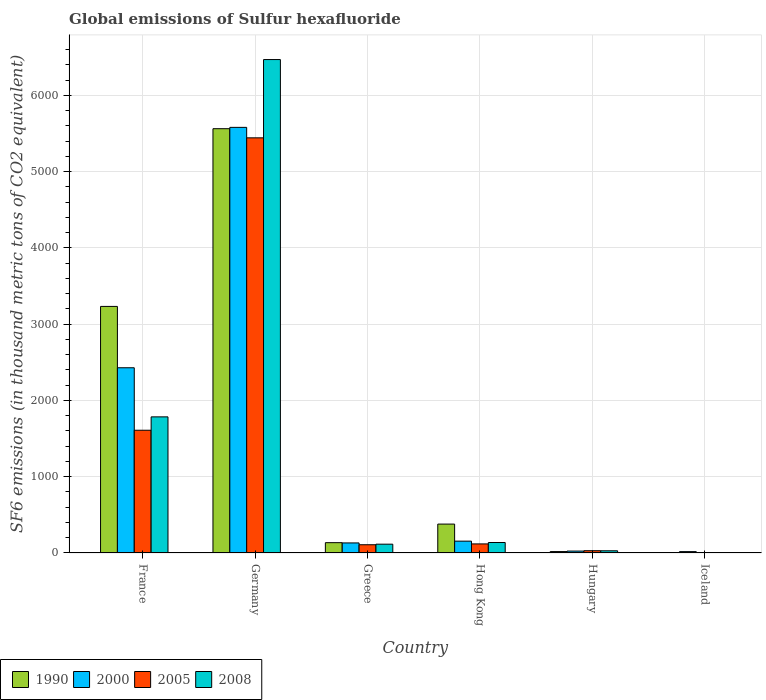How many different coloured bars are there?
Your response must be concise. 4. Are the number of bars per tick equal to the number of legend labels?
Your answer should be very brief. Yes. Are the number of bars on each tick of the X-axis equal?
Offer a terse response. Yes. How many bars are there on the 4th tick from the left?
Offer a terse response. 4. What is the label of the 5th group of bars from the left?
Give a very brief answer. Hungary. Across all countries, what is the maximum global emissions of Sulfur hexafluoride in 2005?
Keep it short and to the point. 5443.2. In which country was the global emissions of Sulfur hexafluoride in 2008 maximum?
Give a very brief answer. Germany. In which country was the global emissions of Sulfur hexafluoride in 2000 minimum?
Your response must be concise. Iceland. What is the total global emissions of Sulfur hexafluoride in 2000 in the graph?
Give a very brief answer. 8339.1. What is the difference between the global emissions of Sulfur hexafluoride in 2005 in France and that in Iceland?
Provide a succinct answer. 1605.9. What is the difference between the global emissions of Sulfur hexafluoride in 1990 in France and the global emissions of Sulfur hexafluoride in 2000 in Germany?
Offer a terse response. -2347.6. What is the average global emissions of Sulfur hexafluoride in 2005 per country?
Provide a succinct answer. 1218.87. What is the difference between the global emissions of Sulfur hexafluoride of/in 2005 and global emissions of Sulfur hexafluoride of/in 2008 in Hong Kong?
Provide a succinct answer. -18.4. What is the ratio of the global emissions of Sulfur hexafluoride in 1990 in Germany to that in Iceland?
Your answer should be compact. 1589.4. Is the global emissions of Sulfur hexafluoride in 1990 in Germany less than that in Hong Kong?
Provide a short and direct response. No. Is the difference between the global emissions of Sulfur hexafluoride in 2005 in France and Hong Kong greater than the difference between the global emissions of Sulfur hexafluoride in 2008 in France and Hong Kong?
Offer a terse response. No. What is the difference between the highest and the second highest global emissions of Sulfur hexafluoride in 1990?
Offer a terse response. -2330.1. What is the difference between the highest and the lowest global emissions of Sulfur hexafluoride in 1990?
Offer a terse response. 5559.4. What does the 3rd bar from the left in Iceland represents?
Offer a very short reply. 2005. What does the 3rd bar from the right in Hungary represents?
Ensure brevity in your answer.  2000. Is it the case that in every country, the sum of the global emissions of Sulfur hexafluoride in 2008 and global emissions of Sulfur hexafluoride in 1990 is greater than the global emissions of Sulfur hexafluoride in 2000?
Offer a very short reply. No. Are all the bars in the graph horizontal?
Your response must be concise. No. How many countries are there in the graph?
Give a very brief answer. 6. What is the difference between two consecutive major ticks on the Y-axis?
Provide a short and direct response. 1000. Are the values on the major ticks of Y-axis written in scientific E-notation?
Offer a terse response. No. How many legend labels are there?
Offer a very short reply. 4. How are the legend labels stacked?
Your response must be concise. Horizontal. What is the title of the graph?
Your response must be concise. Global emissions of Sulfur hexafluoride. Does "1979" appear as one of the legend labels in the graph?
Provide a succinct answer. No. What is the label or title of the X-axis?
Your response must be concise. Country. What is the label or title of the Y-axis?
Provide a short and direct response. SF6 emissions (in thousand metric tons of CO2 equivalent). What is the SF6 emissions (in thousand metric tons of CO2 equivalent) in 1990 in France?
Provide a short and direct response. 3232.8. What is the SF6 emissions (in thousand metric tons of CO2 equivalent) of 2000 in France?
Your response must be concise. 2428.5. What is the SF6 emissions (in thousand metric tons of CO2 equivalent) in 2005 in France?
Offer a very short reply. 1609.4. What is the SF6 emissions (in thousand metric tons of CO2 equivalent) in 2008 in France?
Offer a very short reply. 1784.7. What is the SF6 emissions (in thousand metric tons of CO2 equivalent) of 1990 in Germany?
Make the answer very short. 5562.9. What is the SF6 emissions (in thousand metric tons of CO2 equivalent) in 2000 in Germany?
Provide a succinct answer. 5580.4. What is the SF6 emissions (in thousand metric tons of CO2 equivalent) in 2005 in Germany?
Give a very brief answer. 5443.2. What is the SF6 emissions (in thousand metric tons of CO2 equivalent) in 2008 in Germany?
Give a very brief answer. 6469.6. What is the SF6 emissions (in thousand metric tons of CO2 equivalent) of 1990 in Greece?
Your answer should be compact. 135.4. What is the SF6 emissions (in thousand metric tons of CO2 equivalent) in 2000 in Greece?
Ensure brevity in your answer.  131.8. What is the SF6 emissions (in thousand metric tons of CO2 equivalent) of 2005 in Greece?
Make the answer very short. 108.1. What is the SF6 emissions (in thousand metric tons of CO2 equivalent) of 2008 in Greece?
Keep it short and to the point. 115.4. What is the SF6 emissions (in thousand metric tons of CO2 equivalent) in 1990 in Hong Kong?
Your response must be concise. 379. What is the SF6 emissions (in thousand metric tons of CO2 equivalent) in 2000 in Hong Kong?
Keep it short and to the point. 155.3. What is the SF6 emissions (in thousand metric tons of CO2 equivalent) in 2005 in Hong Kong?
Offer a terse response. 119. What is the SF6 emissions (in thousand metric tons of CO2 equivalent) of 2008 in Hong Kong?
Ensure brevity in your answer.  137.4. What is the SF6 emissions (in thousand metric tons of CO2 equivalent) of 2000 in Hungary?
Provide a short and direct response. 25.2. What is the SF6 emissions (in thousand metric tons of CO2 equivalent) of 2008 in Hungary?
Provide a short and direct response. 28.9. What is the SF6 emissions (in thousand metric tons of CO2 equivalent) of 1990 in Iceland?
Make the answer very short. 3.5. What is the SF6 emissions (in thousand metric tons of CO2 equivalent) in 2005 in Iceland?
Your response must be concise. 3.5. Across all countries, what is the maximum SF6 emissions (in thousand metric tons of CO2 equivalent) in 1990?
Give a very brief answer. 5562.9. Across all countries, what is the maximum SF6 emissions (in thousand metric tons of CO2 equivalent) of 2000?
Provide a short and direct response. 5580.4. Across all countries, what is the maximum SF6 emissions (in thousand metric tons of CO2 equivalent) of 2005?
Provide a succinct answer. 5443.2. Across all countries, what is the maximum SF6 emissions (in thousand metric tons of CO2 equivalent) in 2008?
Your answer should be very brief. 6469.6. Across all countries, what is the minimum SF6 emissions (in thousand metric tons of CO2 equivalent) of 1990?
Keep it short and to the point. 3.5. Across all countries, what is the minimum SF6 emissions (in thousand metric tons of CO2 equivalent) in 2005?
Provide a short and direct response. 3.5. Across all countries, what is the minimum SF6 emissions (in thousand metric tons of CO2 equivalent) in 2008?
Offer a terse response. 4. What is the total SF6 emissions (in thousand metric tons of CO2 equivalent) in 1990 in the graph?
Your response must be concise. 9332.2. What is the total SF6 emissions (in thousand metric tons of CO2 equivalent) of 2000 in the graph?
Provide a succinct answer. 8339.1. What is the total SF6 emissions (in thousand metric tons of CO2 equivalent) in 2005 in the graph?
Your answer should be compact. 7313.2. What is the total SF6 emissions (in thousand metric tons of CO2 equivalent) of 2008 in the graph?
Offer a very short reply. 8540. What is the difference between the SF6 emissions (in thousand metric tons of CO2 equivalent) in 1990 in France and that in Germany?
Offer a terse response. -2330.1. What is the difference between the SF6 emissions (in thousand metric tons of CO2 equivalent) in 2000 in France and that in Germany?
Provide a short and direct response. -3151.9. What is the difference between the SF6 emissions (in thousand metric tons of CO2 equivalent) of 2005 in France and that in Germany?
Your answer should be very brief. -3833.8. What is the difference between the SF6 emissions (in thousand metric tons of CO2 equivalent) in 2008 in France and that in Germany?
Keep it short and to the point. -4684.9. What is the difference between the SF6 emissions (in thousand metric tons of CO2 equivalent) of 1990 in France and that in Greece?
Provide a short and direct response. 3097.4. What is the difference between the SF6 emissions (in thousand metric tons of CO2 equivalent) in 2000 in France and that in Greece?
Give a very brief answer. 2296.7. What is the difference between the SF6 emissions (in thousand metric tons of CO2 equivalent) in 2005 in France and that in Greece?
Provide a succinct answer. 1501.3. What is the difference between the SF6 emissions (in thousand metric tons of CO2 equivalent) of 2008 in France and that in Greece?
Your response must be concise. 1669.3. What is the difference between the SF6 emissions (in thousand metric tons of CO2 equivalent) of 1990 in France and that in Hong Kong?
Make the answer very short. 2853.8. What is the difference between the SF6 emissions (in thousand metric tons of CO2 equivalent) of 2000 in France and that in Hong Kong?
Offer a terse response. 2273.2. What is the difference between the SF6 emissions (in thousand metric tons of CO2 equivalent) of 2005 in France and that in Hong Kong?
Give a very brief answer. 1490.4. What is the difference between the SF6 emissions (in thousand metric tons of CO2 equivalent) in 2008 in France and that in Hong Kong?
Your answer should be compact. 1647.3. What is the difference between the SF6 emissions (in thousand metric tons of CO2 equivalent) in 1990 in France and that in Hungary?
Offer a terse response. 3214.2. What is the difference between the SF6 emissions (in thousand metric tons of CO2 equivalent) in 2000 in France and that in Hungary?
Offer a terse response. 2403.3. What is the difference between the SF6 emissions (in thousand metric tons of CO2 equivalent) of 2005 in France and that in Hungary?
Keep it short and to the point. 1579.4. What is the difference between the SF6 emissions (in thousand metric tons of CO2 equivalent) in 2008 in France and that in Hungary?
Ensure brevity in your answer.  1755.8. What is the difference between the SF6 emissions (in thousand metric tons of CO2 equivalent) in 1990 in France and that in Iceland?
Your response must be concise. 3229.3. What is the difference between the SF6 emissions (in thousand metric tons of CO2 equivalent) in 2000 in France and that in Iceland?
Keep it short and to the point. 2410.6. What is the difference between the SF6 emissions (in thousand metric tons of CO2 equivalent) in 2005 in France and that in Iceland?
Provide a short and direct response. 1605.9. What is the difference between the SF6 emissions (in thousand metric tons of CO2 equivalent) of 2008 in France and that in Iceland?
Provide a succinct answer. 1780.7. What is the difference between the SF6 emissions (in thousand metric tons of CO2 equivalent) in 1990 in Germany and that in Greece?
Provide a short and direct response. 5427.5. What is the difference between the SF6 emissions (in thousand metric tons of CO2 equivalent) of 2000 in Germany and that in Greece?
Give a very brief answer. 5448.6. What is the difference between the SF6 emissions (in thousand metric tons of CO2 equivalent) in 2005 in Germany and that in Greece?
Provide a short and direct response. 5335.1. What is the difference between the SF6 emissions (in thousand metric tons of CO2 equivalent) of 2008 in Germany and that in Greece?
Ensure brevity in your answer.  6354.2. What is the difference between the SF6 emissions (in thousand metric tons of CO2 equivalent) of 1990 in Germany and that in Hong Kong?
Provide a succinct answer. 5183.9. What is the difference between the SF6 emissions (in thousand metric tons of CO2 equivalent) in 2000 in Germany and that in Hong Kong?
Give a very brief answer. 5425.1. What is the difference between the SF6 emissions (in thousand metric tons of CO2 equivalent) of 2005 in Germany and that in Hong Kong?
Provide a succinct answer. 5324.2. What is the difference between the SF6 emissions (in thousand metric tons of CO2 equivalent) in 2008 in Germany and that in Hong Kong?
Your response must be concise. 6332.2. What is the difference between the SF6 emissions (in thousand metric tons of CO2 equivalent) in 1990 in Germany and that in Hungary?
Provide a succinct answer. 5544.3. What is the difference between the SF6 emissions (in thousand metric tons of CO2 equivalent) in 2000 in Germany and that in Hungary?
Your answer should be very brief. 5555.2. What is the difference between the SF6 emissions (in thousand metric tons of CO2 equivalent) in 2005 in Germany and that in Hungary?
Keep it short and to the point. 5413.2. What is the difference between the SF6 emissions (in thousand metric tons of CO2 equivalent) in 2008 in Germany and that in Hungary?
Your response must be concise. 6440.7. What is the difference between the SF6 emissions (in thousand metric tons of CO2 equivalent) in 1990 in Germany and that in Iceland?
Provide a succinct answer. 5559.4. What is the difference between the SF6 emissions (in thousand metric tons of CO2 equivalent) in 2000 in Germany and that in Iceland?
Your answer should be very brief. 5562.5. What is the difference between the SF6 emissions (in thousand metric tons of CO2 equivalent) in 2005 in Germany and that in Iceland?
Your answer should be very brief. 5439.7. What is the difference between the SF6 emissions (in thousand metric tons of CO2 equivalent) in 2008 in Germany and that in Iceland?
Make the answer very short. 6465.6. What is the difference between the SF6 emissions (in thousand metric tons of CO2 equivalent) in 1990 in Greece and that in Hong Kong?
Your answer should be very brief. -243.6. What is the difference between the SF6 emissions (in thousand metric tons of CO2 equivalent) in 2000 in Greece and that in Hong Kong?
Provide a succinct answer. -23.5. What is the difference between the SF6 emissions (in thousand metric tons of CO2 equivalent) of 1990 in Greece and that in Hungary?
Your answer should be compact. 116.8. What is the difference between the SF6 emissions (in thousand metric tons of CO2 equivalent) of 2000 in Greece and that in Hungary?
Make the answer very short. 106.6. What is the difference between the SF6 emissions (in thousand metric tons of CO2 equivalent) of 2005 in Greece and that in Hungary?
Your answer should be very brief. 78.1. What is the difference between the SF6 emissions (in thousand metric tons of CO2 equivalent) of 2008 in Greece and that in Hungary?
Keep it short and to the point. 86.5. What is the difference between the SF6 emissions (in thousand metric tons of CO2 equivalent) in 1990 in Greece and that in Iceland?
Offer a terse response. 131.9. What is the difference between the SF6 emissions (in thousand metric tons of CO2 equivalent) in 2000 in Greece and that in Iceland?
Offer a terse response. 113.9. What is the difference between the SF6 emissions (in thousand metric tons of CO2 equivalent) in 2005 in Greece and that in Iceland?
Offer a terse response. 104.6. What is the difference between the SF6 emissions (in thousand metric tons of CO2 equivalent) of 2008 in Greece and that in Iceland?
Ensure brevity in your answer.  111.4. What is the difference between the SF6 emissions (in thousand metric tons of CO2 equivalent) in 1990 in Hong Kong and that in Hungary?
Your answer should be compact. 360.4. What is the difference between the SF6 emissions (in thousand metric tons of CO2 equivalent) in 2000 in Hong Kong and that in Hungary?
Ensure brevity in your answer.  130.1. What is the difference between the SF6 emissions (in thousand metric tons of CO2 equivalent) of 2005 in Hong Kong and that in Hungary?
Provide a succinct answer. 89. What is the difference between the SF6 emissions (in thousand metric tons of CO2 equivalent) of 2008 in Hong Kong and that in Hungary?
Keep it short and to the point. 108.5. What is the difference between the SF6 emissions (in thousand metric tons of CO2 equivalent) in 1990 in Hong Kong and that in Iceland?
Give a very brief answer. 375.5. What is the difference between the SF6 emissions (in thousand metric tons of CO2 equivalent) in 2000 in Hong Kong and that in Iceland?
Offer a very short reply. 137.4. What is the difference between the SF6 emissions (in thousand metric tons of CO2 equivalent) of 2005 in Hong Kong and that in Iceland?
Ensure brevity in your answer.  115.5. What is the difference between the SF6 emissions (in thousand metric tons of CO2 equivalent) in 2008 in Hong Kong and that in Iceland?
Ensure brevity in your answer.  133.4. What is the difference between the SF6 emissions (in thousand metric tons of CO2 equivalent) in 1990 in Hungary and that in Iceland?
Offer a terse response. 15.1. What is the difference between the SF6 emissions (in thousand metric tons of CO2 equivalent) in 2000 in Hungary and that in Iceland?
Your answer should be compact. 7.3. What is the difference between the SF6 emissions (in thousand metric tons of CO2 equivalent) of 2005 in Hungary and that in Iceland?
Offer a very short reply. 26.5. What is the difference between the SF6 emissions (in thousand metric tons of CO2 equivalent) in 2008 in Hungary and that in Iceland?
Provide a short and direct response. 24.9. What is the difference between the SF6 emissions (in thousand metric tons of CO2 equivalent) of 1990 in France and the SF6 emissions (in thousand metric tons of CO2 equivalent) of 2000 in Germany?
Offer a terse response. -2347.6. What is the difference between the SF6 emissions (in thousand metric tons of CO2 equivalent) in 1990 in France and the SF6 emissions (in thousand metric tons of CO2 equivalent) in 2005 in Germany?
Keep it short and to the point. -2210.4. What is the difference between the SF6 emissions (in thousand metric tons of CO2 equivalent) in 1990 in France and the SF6 emissions (in thousand metric tons of CO2 equivalent) in 2008 in Germany?
Offer a terse response. -3236.8. What is the difference between the SF6 emissions (in thousand metric tons of CO2 equivalent) of 2000 in France and the SF6 emissions (in thousand metric tons of CO2 equivalent) of 2005 in Germany?
Give a very brief answer. -3014.7. What is the difference between the SF6 emissions (in thousand metric tons of CO2 equivalent) in 2000 in France and the SF6 emissions (in thousand metric tons of CO2 equivalent) in 2008 in Germany?
Ensure brevity in your answer.  -4041.1. What is the difference between the SF6 emissions (in thousand metric tons of CO2 equivalent) of 2005 in France and the SF6 emissions (in thousand metric tons of CO2 equivalent) of 2008 in Germany?
Offer a very short reply. -4860.2. What is the difference between the SF6 emissions (in thousand metric tons of CO2 equivalent) of 1990 in France and the SF6 emissions (in thousand metric tons of CO2 equivalent) of 2000 in Greece?
Offer a very short reply. 3101. What is the difference between the SF6 emissions (in thousand metric tons of CO2 equivalent) of 1990 in France and the SF6 emissions (in thousand metric tons of CO2 equivalent) of 2005 in Greece?
Give a very brief answer. 3124.7. What is the difference between the SF6 emissions (in thousand metric tons of CO2 equivalent) of 1990 in France and the SF6 emissions (in thousand metric tons of CO2 equivalent) of 2008 in Greece?
Ensure brevity in your answer.  3117.4. What is the difference between the SF6 emissions (in thousand metric tons of CO2 equivalent) in 2000 in France and the SF6 emissions (in thousand metric tons of CO2 equivalent) in 2005 in Greece?
Provide a short and direct response. 2320.4. What is the difference between the SF6 emissions (in thousand metric tons of CO2 equivalent) of 2000 in France and the SF6 emissions (in thousand metric tons of CO2 equivalent) of 2008 in Greece?
Provide a short and direct response. 2313.1. What is the difference between the SF6 emissions (in thousand metric tons of CO2 equivalent) of 2005 in France and the SF6 emissions (in thousand metric tons of CO2 equivalent) of 2008 in Greece?
Offer a terse response. 1494. What is the difference between the SF6 emissions (in thousand metric tons of CO2 equivalent) of 1990 in France and the SF6 emissions (in thousand metric tons of CO2 equivalent) of 2000 in Hong Kong?
Your answer should be compact. 3077.5. What is the difference between the SF6 emissions (in thousand metric tons of CO2 equivalent) of 1990 in France and the SF6 emissions (in thousand metric tons of CO2 equivalent) of 2005 in Hong Kong?
Ensure brevity in your answer.  3113.8. What is the difference between the SF6 emissions (in thousand metric tons of CO2 equivalent) of 1990 in France and the SF6 emissions (in thousand metric tons of CO2 equivalent) of 2008 in Hong Kong?
Provide a short and direct response. 3095.4. What is the difference between the SF6 emissions (in thousand metric tons of CO2 equivalent) in 2000 in France and the SF6 emissions (in thousand metric tons of CO2 equivalent) in 2005 in Hong Kong?
Provide a short and direct response. 2309.5. What is the difference between the SF6 emissions (in thousand metric tons of CO2 equivalent) of 2000 in France and the SF6 emissions (in thousand metric tons of CO2 equivalent) of 2008 in Hong Kong?
Your response must be concise. 2291.1. What is the difference between the SF6 emissions (in thousand metric tons of CO2 equivalent) in 2005 in France and the SF6 emissions (in thousand metric tons of CO2 equivalent) in 2008 in Hong Kong?
Your answer should be very brief. 1472. What is the difference between the SF6 emissions (in thousand metric tons of CO2 equivalent) in 1990 in France and the SF6 emissions (in thousand metric tons of CO2 equivalent) in 2000 in Hungary?
Provide a succinct answer. 3207.6. What is the difference between the SF6 emissions (in thousand metric tons of CO2 equivalent) in 1990 in France and the SF6 emissions (in thousand metric tons of CO2 equivalent) in 2005 in Hungary?
Offer a terse response. 3202.8. What is the difference between the SF6 emissions (in thousand metric tons of CO2 equivalent) in 1990 in France and the SF6 emissions (in thousand metric tons of CO2 equivalent) in 2008 in Hungary?
Your answer should be compact. 3203.9. What is the difference between the SF6 emissions (in thousand metric tons of CO2 equivalent) of 2000 in France and the SF6 emissions (in thousand metric tons of CO2 equivalent) of 2005 in Hungary?
Offer a terse response. 2398.5. What is the difference between the SF6 emissions (in thousand metric tons of CO2 equivalent) in 2000 in France and the SF6 emissions (in thousand metric tons of CO2 equivalent) in 2008 in Hungary?
Offer a terse response. 2399.6. What is the difference between the SF6 emissions (in thousand metric tons of CO2 equivalent) of 2005 in France and the SF6 emissions (in thousand metric tons of CO2 equivalent) of 2008 in Hungary?
Offer a terse response. 1580.5. What is the difference between the SF6 emissions (in thousand metric tons of CO2 equivalent) in 1990 in France and the SF6 emissions (in thousand metric tons of CO2 equivalent) in 2000 in Iceland?
Give a very brief answer. 3214.9. What is the difference between the SF6 emissions (in thousand metric tons of CO2 equivalent) of 1990 in France and the SF6 emissions (in thousand metric tons of CO2 equivalent) of 2005 in Iceland?
Make the answer very short. 3229.3. What is the difference between the SF6 emissions (in thousand metric tons of CO2 equivalent) of 1990 in France and the SF6 emissions (in thousand metric tons of CO2 equivalent) of 2008 in Iceland?
Your response must be concise. 3228.8. What is the difference between the SF6 emissions (in thousand metric tons of CO2 equivalent) in 2000 in France and the SF6 emissions (in thousand metric tons of CO2 equivalent) in 2005 in Iceland?
Offer a terse response. 2425. What is the difference between the SF6 emissions (in thousand metric tons of CO2 equivalent) of 2000 in France and the SF6 emissions (in thousand metric tons of CO2 equivalent) of 2008 in Iceland?
Give a very brief answer. 2424.5. What is the difference between the SF6 emissions (in thousand metric tons of CO2 equivalent) in 2005 in France and the SF6 emissions (in thousand metric tons of CO2 equivalent) in 2008 in Iceland?
Your answer should be very brief. 1605.4. What is the difference between the SF6 emissions (in thousand metric tons of CO2 equivalent) of 1990 in Germany and the SF6 emissions (in thousand metric tons of CO2 equivalent) of 2000 in Greece?
Your answer should be very brief. 5431.1. What is the difference between the SF6 emissions (in thousand metric tons of CO2 equivalent) in 1990 in Germany and the SF6 emissions (in thousand metric tons of CO2 equivalent) in 2005 in Greece?
Ensure brevity in your answer.  5454.8. What is the difference between the SF6 emissions (in thousand metric tons of CO2 equivalent) in 1990 in Germany and the SF6 emissions (in thousand metric tons of CO2 equivalent) in 2008 in Greece?
Keep it short and to the point. 5447.5. What is the difference between the SF6 emissions (in thousand metric tons of CO2 equivalent) in 2000 in Germany and the SF6 emissions (in thousand metric tons of CO2 equivalent) in 2005 in Greece?
Make the answer very short. 5472.3. What is the difference between the SF6 emissions (in thousand metric tons of CO2 equivalent) in 2000 in Germany and the SF6 emissions (in thousand metric tons of CO2 equivalent) in 2008 in Greece?
Keep it short and to the point. 5465. What is the difference between the SF6 emissions (in thousand metric tons of CO2 equivalent) in 2005 in Germany and the SF6 emissions (in thousand metric tons of CO2 equivalent) in 2008 in Greece?
Offer a terse response. 5327.8. What is the difference between the SF6 emissions (in thousand metric tons of CO2 equivalent) of 1990 in Germany and the SF6 emissions (in thousand metric tons of CO2 equivalent) of 2000 in Hong Kong?
Keep it short and to the point. 5407.6. What is the difference between the SF6 emissions (in thousand metric tons of CO2 equivalent) in 1990 in Germany and the SF6 emissions (in thousand metric tons of CO2 equivalent) in 2005 in Hong Kong?
Give a very brief answer. 5443.9. What is the difference between the SF6 emissions (in thousand metric tons of CO2 equivalent) of 1990 in Germany and the SF6 emissions (in thousand metric tons of CO2 equivalent) of 2008 in Hong Kong?
Give a very brief answer. 5425.5. What is the difference between the SF6 emissions (in thousand metric tons of CO2 equivalent) in 2000 in Germany and the SF6 emissions (in thousand metric tons of CO2 equivalent) in 2005 in Hong Kong?
Provide a succinct answer. 5461.4. What is the difference between the SF6 emissions (in thousand metric tons of CO2 equivalent) of 2000 in Germany and the SF6 emissions (in thousand metric tons of CO2 equivalent) of 2008 in Hong Kong?
Provide a short and direct response. 5443. What is the difference between the SF6 emissions (in thousand metric tons of CO2 equivalent) in 2005 in Germany and the SF6 emissions (in thousand metric tons of CO2 equivalent) in 2008 in Hong Kong?
Provide a succinct answer. 5305.8. What is the difference between the SF6 emissions (in thousand metric tons of CO2 equivalent) of 1990 in Germany and the SF6 emissions (in thousand metric tons of CO2 equivalent) of 2000 in Hungary?
Offer a terse response. 5537.7. What is the difference between the SF6 emissions (in thousand metric tons of CO2 equivalent) of 1990 in Germany and the SF6 emissions (in thousand metric tons of CO2 equivalent) of 2005 in Hungary?
Offer a very short reply. 5532.9. What is the difference between the SF6 emissions (in thousand metric tons of CO2 equivalent) of 1990 in Germany and the SF6 emissions (in thousand metric tons of CO2 equivalent) of 2008 in Hungary?
Keep it short and to the point. 5534. What is the difference between the SF6 emissions (in thousand metric tons of CO2 equivalent) in 2000 in Germany and the SF6 emissions (in thousand metric tons of CO2 equivalent) in 2005 in Hungary?
Provide a succinct answer. 5550.4. What is the difference between the SF6 emissions (in thousand metric tons of CO2 equivalent) of 2000 in Germany and the SF6 emissions (in thousand metric tons of CO2 equivalent) of 2008 in Hungary?
Give a very brief answer. 5551.5. What is the difference between the SF6 emissions (in thousand metric tons of CO2 equivalent) in 2005 in Germany and the SF6 emissions (in thousand metric tons of CO2 equivalent) in 2008 in Hungary?
Give a very brief answer. 5414.3. What is the difference between the SF6 emissions (in thousand metric tons of CO2 equivalent) in 1990 in Germany and the SF6 emissions (in thousand metric tons of CO2 equivalent) in 2000 in Iceland?
Your answer should be very brief. 5545. What is the difference between the SF6 emissions (in thousand metric tons of CO2 equivalent) of 1990 in Germany and the SF6 emissions (in thousand metric tons of CO2 equivalent) of 2005 in Iceland?
Offer a terse response. 5559.4. What is the difference between the SF6 emissions (in thousand metric tons of CO2 equivalent) of 1990 in Germany and the SF6 emissions (in thousand metric tons of CO2 equivalent) of 2008 in Iceland?
Your response must be concise. 5558.9. What is the difference between the SF6 emissions (in thousand metric tons of CO2 equivalent) in 2000 in Germany and the SF6 emissions (in thousand metric tons of CO2 equivalent) in 2005 in Iceland?
Keep it short and to the point. 5576.9. What is the difference between the SF6 emissions (in thousand metric tons of CO2 equivalent) in 2000 in Germany and the SF6 emissions (in thousand metric tons of CO2 equivalent) in 2008 in Iceland?
Your answer should be compact. 5576.4. What is the difference between the SF6 emissions (in thousand metric tons of CO2 equivalent) in 2005 in Germany and the SF6 emissions (in thousand metric tons of CO2 equivalent) in 2008 in Iceland?
Make the answer very short. 5439.2. What is the difference between the SF6 emissions (in thousand metric tons of CO2 equivalent) in 1990 in Greece and the SF6 emissions (in thousand metric tons of CO2 equivalent) in 2000 in Hong Kong?
Provide a succinct answer. -19.9. What is the difference between the SF6 emissions (in thousand metric tons of CO2 equivalent) of 1990 in Greece and the SF6 emissions (in thousand metric tons of CO2 equivalent) of 2005 in Hong Kong?
Keep it short and to the point. 16.4. What is the difference between the SF6 emissions (in thousand metric tons of CO2 equivalent) of 1990 in Greece and the SF6 emissions (in thousand metric tons of CO2 equivalent) of 2008 in Hong Kong?
Your answer should be very brief. -2. What is the difference between the SF6 emissions (in thousand metric tons of CO2 equivalent) of 2000 in Greece and the SF6 emissions (in thousand metric tons of CO2 equivalent) of 2005 in Hong Kong?
Your answer should be compact. 12.8. What is the difference between the SF6 emissions (in thousand metric tons of CO2 equivalent) in 2005 in Greece and the SF6 emissions (in thousand metric tons of CO2 equivalent) in 2008 in Hong Kong?
Provide a short and direct response. -29.3. What is the difference between the SF6 emissions (in thousand metric tons of CO2 equivalent) of 1990 in Greece and the SF6 emissions (in thousand metric tons of CO2 equivalent) of 2000 in Hungary?
Offer a terse response. 110.2. What is the difference between the SF6 emissions (in thousand metric tons of CO2 equivalent) of 1990 in Greece and the SF6 emissions (in thousand metric tons of CO2 equivalent) of 2005 in Hungary?
Provide a short and direct response. 105.4. What is the difference between the SF6 emissions (in thousand metric tons of CO2 equivalent) of 1990 in Greece and the SF6 emissions (in thousand metric tons of CO2 equivalent) of 2008 in Hungary?
Ensure brevity in your answer.  106.5. What is the difference between the SF6 emissions (in thousand metric tons of CO2 equivalent) in 2000 in Greece and the SF6 emissions (in thousand metric tons of CO2 equivalent) in 2005 in Hungary?
Ensure brevity in your answer.  101.8. What is the difference between the SF6 emissions (in thousand metric tons of CO2 equivalent) of 2000 in Greece and the SF6 emissions (in thousand metric tons of CO2 equivalent) of 2008 in Hungary?
Your answer should be compact. 102.9. What is the difference between the SF6 emissions (in thousand metric tons of CO2 equivalent) in 2005 in Greece and the SF6 emissions (in thousand metric tons of CO2 equivalent) in 2008 in Hungary?
Your response must be concise. 79.2. What is the difference between the SF6 emissions (in thousand metric tons of CO2 equivalent) in 1990 in Greece and the SF6 emissions (in thousand metric tons of CO2 equivalent) in 2000 in Iceland?
Provide a succinct answer. 117.5. What is the difference between the SF6 emissions (in thousand metric tons of CO2 equivalent) of 1990 in Greece and the SF6 emissions (in thousand metric tons of CO2 equivalent) of 2005 in Iceland?
Your response must be concise. 131.9. What is the difference between the SF6 emissions (in thousand metric tons of CO2 equivalent) in 1990 in Greece and the SF6 emissions (in thousand metric tons of CO2 equivalent) in 2008 in Iceland?
Give a very brief answer. 131.4. What is the difference between the SF6 emissions (in thousand metric tons of CO2 equivalent) in 2000 in Greece and the SF6 emissions (in thousand metric tons of CO2 equivalent) in 2005 in Iceland?
Offer a terse response. 128.3. What is the difference between the SF6 emissions (in thousand metric tons of CO2 equivalent) of 2000 in Greece and the SF6 emissions (in thousand metric tons of CO2 equivalent) of 2008 in Iceland?
Offer a terse response. 127.8. What is the difference between the SF6 emissions (in thousand metric tons of CO2 equivalent) of 2005 in Greece and the SF6 emissions (in thousand metric tons of CO2 equivalent) of 2008 in Iceland?
Ensure brevity in your answer.  104.1. What is the difference between the SF6 emissions (in thousand metric tons of CO2 equivalent) in 1990 in Hong Kong and the SF6 emissions (in thousand metric tons of CO2 equivalent) in 2000 in Hungary?
Make the answer very short. 353.8. What is the difference between the SF6 emissions (in thousand metric tons of CO2 equivalent) of 1990 in Hong Kong and the SF6 emissions (in thousand metric tons of CO2 equivalent) of 2005 in Hungary?
Offer a very short reply. 349. What is the difference between the SF6 emissions (in thousand metric tons of CO2 equivalent) in 1990 in Hong Kong and the SF6 emissions (in thousand metric tons of CO2 equivalent) in 2008 in Hungary?
Your response must be concise. 350.1. What is the difference between the SF6 emissions (in thousand metric tons of CO2 equivalent) of 2000 in Hong Kong and the SF6 emissions (in thousand metric tons of CO2 equivalent) of 2005 in Hungary?
Offer a very short reply. 125.3. What is the difference between the SF6 emissions (in thousand metric tons of CO2 equivalent) of 2000 in Hong Kong and the SF6 emissions (in thousand metric tons of CO2 equivalent) of 2008 in Hungary?
Your answer should be very brief. 126.4. What is the difference between the SF6 emissions (in thousand metric tons of CO2 equivalent) of 2005 in Hong Kong and the SF6 emissions (in thousand metric tons of CO2 equivalent) of 2008 in Hungary?
Keep it short and to the point. 90.1. What is the difference between the SF6 emissions (in thousand metric tons of CO2 equivalent) in 1990 in Hong Kong and the SF6 emissions (in thousand metric tons of CO2 equivalent) in 2000 in Iceland?
Keep it short and to the point. 361.1. What is the difference between the SF6 emissions (in thousand metric tons of CO2 equivalent) in 1990 in Hong Kong and the SF6 emissions (in thousand metric tons of CO2 equivalent) in 2005 in Iceland?
Offer a very short reply. 375.5. What is the difference between the SF6 emissions (in thousand metric tons of CO2 equivalent) of 1990 in Hong Kong and the SF6 emissions (in thousand metric tons of CO2 equivalent) of 2008 in Iceland?
Your answer should be very brief. 375. What is the difference between the SF6 emissions (in thousand metric tons of CO2 equivalent) of 2000 in Hong Kong and the SF6 emissions (in thousand metric tons of CO2 equivalent) of 2005 in Iceland?
Your response must be concise. 151.8. What is the difference between the SF6 emissions (in thousand metric tons of CO2 equivalent) in 2000 in Hong Kong and the SF6 emissions (in thousand metric tons of CO2 equivalent) in 2008 in Iceland?
Provide a succinct answer. 151.3. What is the difference between the SF6 emissions (in thousand metric tons of CO2 equivalent) of 2005 in Hong Kong and the SF6 emissions (in thousand metric tons of CO2 equivalent) of 2008 in Iceland?
Give a very brief answer. 115. What is the difference between the SF6 emissions (in thousand metric tons of CO2 equivalent) in 1990 in Hungary and the SF6 emissions (in thousand metric tons of CO2 equivalent) in 2000 in Iceland?
Ensure brevity in your answer.  0.7. What is the difference between the SF6 emissions (in thousand metric tons of CO2 equivalent) in 2000 in Hungary and the SF6 emissions (in thousand metric tons of CO2 equivalent) in 2005 in Iceland?
Make the answer very short. 21.7. What is the difference between the SF6 emissions (in thousand metric tons of CO2 equivalent) in 2000 in Hungary and the SF6 emissions (in thousand metric tons of CO2 equivalent) in 2008 in Iceland?
Keep it short and to the point. 21.2. What is the difference between the SF6 emissions (in thousand metric tons of CO2 equivalent) in 2005 in Hungary and the SF6 emissions (in thousand metric tons of CO2 equivalent) in 2008 in Iceland?
Provide a succinct answer. 26. What is the average SF6 emissions (in thousand metric tons of CO2 equivalent) in 1990 per country?
Your answer should be very brief. 1555.37. What is the average SF6 emissions (in thousand metric tons of CO2 equivalent) of 2000 per country?
Ensure brevity in your answer.  1389.85. What is the average SF6 emissions (in thousand metric tons of CO2 equivalent) of 2005 per country?
Keep it short and to the point. 1218.87. What is the average SF6 emissions (in thousand metric tons of CO2 equivalent) in 2008 per country?
Your response must be concise. 1423.33. What is the difference between the SF6 emissions (in thousand metric tons of CO2 equivalent) in 1990 and SF6 emissions (in thousand metric tons of CO2 equivalent) in 2000 in France?
Offer a terse response. 804.3. What is the difference between the SF6 emissions (in thousand metric tons of CO2 equivalent) of 1990 and SF6 emissions (in thousand metric tons of CO2 equivalent) of 2005 in France?
Provide a succinct answer. 1623.4. What is the difference between the SF6 emissions (in thousand metric tons of CO2 equivalent) of 1990 and SF6 emissions (in thousand metric tons of CO2 equivalent) of 2008 in France?
Keep it short and to the point. 1448.1. What is the difference between the SF6 emissions (in thousand metric tons of CO2 equivalent) of 2000 and SF6 emissions (in thousand metric tons of CO2 equivalent) of 2005 in France?
Give a very brief answer. 819.1. What is the difference between the SF6 emissions (in thousand metric tons of CO2 equivalent) in 2000 and SF6 emissions (in thousand metric tons of CO2 equivalent) in 2008 in France?
Your answer should be compact. 643.8. What is the difference between the SF6 emissions (in thousand metric tons of CO2 equivalent) of 2005 and SF6 emissions (in thousand metric tons of CO2 equivalent) of 2008 in France?
Your answer should be very brief. -175.3. What is the difference between the SF6 emissions (in thousand metric tons of CO2 equivalent) in 1990 and SF6 emissions (in thousand metric tons of CO2 equivalent) in 2000 in Germany?
Make the answer very short. -17.5. What is the difference between the SF6 emissions (in thousand metric tons of CO2 equivalent) of 1990 and SF6 emissions (in thousand metric tons of CO2 equivalent) of 2005 in Germany?
Provide a short and direct response. 119.7. What is the difference between the SF6 emissions (in thousand metric tons of CO2 equivalent) of 1990 and SF6 emissions (in thousand metric tons of CO2 equivalent) of 2008 in Germany?
Keep it short and to the point. -906.7. What is the difference between the SF6 emissions (in thousand metric tons of CO2 equivalent) of 2000 and SF6 emissions (in thousand metric tons of CO2 equivalent) of 2005 in Germany?
Provide a succinct answer. 137.2. What is the difference between the SF6 emissions (in thousand metric tons of CO2 equivalent) in 2000 and SF6 emissions (in thousand metric tons of CO2 equivalent) in 2008 in Germany?
Offer a terse response. -889.2. What is the difference between the SF6 emissions (in thousand metric tons of CO2 equivalent) in 2005 and SF6 emissions (in thousand metric tons of CO2 equivalent) in 2008 in Germany?
Ensure brevity in your answer.  -1026.4. What is the difference between the SF6 emissions (in thousand metric tons of CO2 equivalent) of 1990 and SF6 emissions (in thousand metric tons of CO2 equivalent) of 2000 in Greece?
Offer a terse response. 3.6. What is the difference between the SF6 emissions (in thousand metric tons of CO2 equivalent) in 1990 and SF6 emissions (in thousand metric tons of CO2 equivalent) in 2005 in Greece?
Make the answer very short. 27.3. What is the difference between the SF6 emissions (in thousand metric tons of CO2 equivalent) of 1990 and SF6 emissions (in thousand metric tons of CO2 equivalent) of 2008 in Greece?
Give a very brief answer. 20. What is the difference between the SF6 emissions (in thousand metric tons of CO2 equivalent) of 2000 and SF6 emissions (in thousand metric tons of CO2 equivalent) of 2005 in Greece?
Offer a terse response. 23.7. What is the difference between the SF6 emissions (in thousand metric tons of CO2 equivalent) in 2000 and SF6 emissions (in thousand metric tons of CO2 equivalent) in 2008 in Greece?
Your response must be concise. 16.4. What is the difference between the SF6 emissions (in thousand metric tons of CO2 equivalent) of 2005 and SF6 emissions (in thousand metric tons of CO2 equivalent) of 2008 in Greece?
Provide a succinct answer. -7.3. What is the difference between the SF6 emissions (in thousand metric tons of CO2 equivalent) in 1990 and SF6 emissions (in thousand metric tons of CO2 equivalent) in 2000 in Hong Kong?
Offer a terse response. 223.7. What is the difference between the SF6 emissions (in thousand metric tons of CO2 equivalent) of 1990 and SF6 emissions (in thousand metric tons of CO2 equivalent) of 2005 in Hong Kong?
Your answer should be compact. 260. What is the difference between the SF6 emissions (in thousand metric tons of CO2 equivalent) in 1990 and SF6 emissions (in thousand metric tons of CO2 equivalent) in 2008 in Hong Kong?
Give a very brief answer. 241.6. What is the difference between the SF6 emissions (in thousand metric tons of CO2 equivalent) in 2000 and SF6 emissions (in thousand metric tons of CO2 equivalent) in 2005 in Hong Kong?
Your response must be concise. 36.3. What is the difference between the SF6 emissions (in thousand metric tons of CO2 equivalent) in 2000 and SF6 emissions (in thousand metric tons of CO2 equivalent) in 2008 in Hong Kong?
Your answer should be compact. 17.9. What is the difference between the SF6 emissions (in thousand metric tons of CO2 equivalent) of 2005 and SF6 emissions (in thousand metric tons of CO2 equivalent) of 2008 in Hong Kong?
Keep it short and to the point. -18.4. What is the difference between the SF6 emissions (in thousand metric tons of CO2 equivalent) of 1990 and SF6 emissions (in thousand metric tons of CO2 equivalent) of 2005 in Hungary?
Provide a short and direct response. -11.4. What is the difference between the SF6 emissions (in thousand metric tons of CO2 equivalent) of 1990 and SF6 emissions (in thousand metric tons of CO2 equivalent) of 2008 in Hungary?
Provide a short and direct response. -10.3. What is the difference between the SF6 emissions (in thousand metric tons of CO2 equivalent) in 2005 and SF6 emissions (in thousand metric tons of CO2 equivalent) in 2008 in Hungary?
Offer a terse response. 1.1. What is the difference between the SF6 emissions (in thousand metric tons of CO2 equivalent) in 1990 and SF6 emissions (in thousand metric tons of CO2 equivalent) in 2000 in Iceland?
Give a very brief answer. -14.4. What is the difference between the SF6 emissions (in thousand metric tons of CO2 equivalent) of 2000 and SF6 emissions (in thousand metric tons of CO2 equivalent) of 2005 in Iceland?
Your answer should be very brief. 14.4. What is the ratio of the SF6 emissions (in thousand metric tons of CO2 equivalent) of 1990 in France to that in Germany?
Provide a short and direct response. 0.58. What is the ratio of the SF6 emissions (in thousand metric tons of CO2 equivalent) in 2000 in France to that in Germany?
Ensure brevity in your answer.  0.44. What is the ratio of the SF6 emissions (in thousand metric tons of CO2 equivalent) of 2005 in France to that in Germany?
Ensure brevity in your answer.  0.3. What is the ratio of the SF6 emissions (in thousand metric tons of CO2 equivalent) in 2008 in France to that in Germany?
Your response must be concise. 0.28. What is the ratio of the SF6 emissions (in thousand metric tons of CO2 equivalent) of 1990 in France to that in Greece?
Your answer should be compact. 23.88. What is the ratio of the SF6 emissions (in thousand metric tons of CO2 equivalent) in 2000 in France to that in Greece?
Offer a very short reply. 18.43. What is the ratio of the SF6 emissions (in thousand metric tons of CO2 equivalent) in 2005 in France to that in Greece?
Ensure brevity in your answer.  14.89. What is the ratio of the SF6 emissions (in thousand metric tons of CO2 equivalent) in 2008 in France to that in Greece?
Give a very brief answer. 15.47. What is the ratio of the SF6 emissions (in thousand metric tons of CO2 equivalent) in 1990 in France to that in Hong Kong?
Offer a very short reply. 8.53. What is the ratio of the SF6 emissions (in thousand metric tons of CO2 equivalent) in 2000 in France to that in Hong Kong?
Provide a succinct answer. 15.64. What is the ratio of the SF6 emissions (in thousand metric tons of CO2 equivalent) of 2005 in France to that in Hong Kong?
Make the answer very short. 13.52. What is the ratio of the SF6 emissions (in thousand metric tons of CO2 equivalent) of 2008 in France to that in Hong Kong?
Keep it short and to the point. 12.99. What is the ratio of the SF6 emissions (in thousand metric tons of CO2 equivalent) of 1990 in France to that in Hungary?
Make the answer very short. 173.81. What is the ratio of the SF6 emissions (in thousand metric tons of CO2 equivalent) in 2000 in France to that in Hungary?
Your answer should be very brief. 96.37. What is the ratio of the SF6 emissions (in thousand metric tons of CO2 equivalent) of 2005 in France to that in Hungary?
Offer a terse response. 53.65. What is the ratio of the SF6 emissions (in thousand metric tons of CO2 equivalent) of 2008 in France to that in Hungary?
Provide a succinct answer. 61.75. What is the ratio of the SF6 emissions (in thousand metric tons of CO2 equivalent) in 1990 in France to that in Iceland?
Your answer should be very brief. 923.66. What is the ratio of the SF6 emissions (in thousand metric tons of CO2 equivalent) in 2000 in France to that in Iceland?
Offer a very short reply. 135.67. What is the ratio of the SF6 emissions (in thousand metric tons of CO2 equivalent) of 2005 in France to that in Iceland?
Give a very brief answer. 459.83. What is the ratio of the SF6 emissions (in thousand metric tons of CO2 equivalent) of 2008 in France to that in Iceland?
Offer a very short reply. 446.18. What is the ratio of the SF6 emissions (in thousand metric tons of CO2 equivalent) in 1990 in Germany to that in Greece?
Keep it short and to the point. 41.08. What is the ratio of the SF6 emissions (in thousand metric tons of CO2 equivalent) of 2000 in Germany to that in Greece?
Offer a very short reply. 42.34. What is the ratio of the SF6 emissions (in thousand metric tons of CO2 equivalent) of 2005 in Germany to that in Greece?
Your response must be concise. 50.35. What is the ratio of the SF6 emissions (in thousand metric tons of CO2 equivalent) of 2008 in Germany to that in Greece?
Provide a short and direct response. 56.06. What is the ratio of the SF6 emissions (in thousand metric tons of CO2 equivalent) of 1990 in Germany to that in Hong Kong?
Ensure brevity in your answer.  14.68. What is the ratio of the SF6 emissions (in thousand metric tons of CO2 equivalent) of 2000 in Germany to that in Hong Kong?
Provide a succinct answer. 35.93. What is the ratio of the SF6 emissions (in thousand metric tons of CO2 equivalent) of 2005 in Germany to that in Hong Kong?
Your answer should be compact. 45.74. What is the ratio of the SF6 emissions (in thousand metric tons of CO2 equivalent) in 2008 in Germany to that in Hong Kong?
Your answer should be compact. 47.09. What is the ratio of the SF6 emissions (in thousand metric tons of CO2 equivalent) of 1990 in Germany to that in Hungary?
Offer a very short reply. 299.08. What is the ratio of the SF6 emissions (in thousand metric tons of CO2 equivalent) of 2000 in Germany to that in Hungary?
Offer a very short reply. 221.44. What is the ratio of the SF6 emissions (in thousand metric tons of CO2 equivalent) of 2005 in Germany to that in Hungary?
Your response must be concise. 181.44. What is the ratio of the SF6 emissions (in thousand metric tons of CO2 equivalent) in 2008 in Germany to that in Hungary?
Provide a succinct answer. 223.86. What is the ratio of the SF6 emissions (in thousand metric tons of CO2 equivalent) in 1990 in Germany to that in Iceland?
Keep it short and to the point. 1589.4. What is the ratio of the SF6 emissions (in thousand metric tons of CO2 equivalent) in 2000 in Germany to that in Iceland?
Your response must be concise. 311.75. What is the ratio of the SF6 emissions (in thousand metric tons of CO2 equivalent) of 2005 in Germany to that in Iceland?
Make the answer very short. 1555.2. What is the ratio of the SF6 emissions (in thousand metric tons of CO2 equivalent) in 2008 in Germany to that in Iceland?
Provide a succinct answer. 1617.4. What is the ratio of the SF6 emissions (in thousand metric tons of CO2 equivalent) of 1990 in Greece to that in Hong Kong?
Your answer should be compact. 0.36. What is the ratio of the SF6 emissions (in thousand metric tons of CO2 equivalent) of 2000 in Greece to that in Hong Kong?
Make the answer very short. 0.85. What is the ratio of the SF6 emissions (in thousand metric tons of CO2 equivalent) of 2005 in Greece to that in Hong Kong?
Make the answer very short. 0.91. What is the ratio of the SF6 emissions (in thousand metric tons of CO2 equivalent) in 2008 in Greece to that in Hong Kong?
Offer a terse response. 0.84. What is the ratio of the SF6 emissions (in thousand metric tons of CO2 equivalent) of 1990 in Greece to that in Hungary?
Ensure brevity in your answer.  7.28. What is the ratio of the SF6 emissions (in thousand metric tons of CO2 equivalent) of 2000 in Greece to that in Hungary?
Give a very brief answer. 5.23. What is the ratio of the SF6 emissions (in thousand metric tons of CO2 equivalent) in 2005 in Greece to that in Hungary?
Your answer should be compact. 3.6. What is the ratio of the SF6 emissions (in thousand metric tons of CO2 equivalent) of 2008 in Greece to that in Hungary?
Your response must be concise. 3.99. What is the ratio of the SF6 emissions (in thousand metric tons of CO2 equivalent) in 1990 in Greece to that in Iceland?
Give a very brief answer. 38.69. What is the ratio of the SF6 emissions (in thousand metric tons of CO2 equivalent) in 2000 in Greece to that in Iceland?
Offer a very short reply. 7.36. What is the ratio of the SF6 emissions (in thousand metric tons of CO2 equivalent) of 2005 in Greece to that in Iceland?
Provide a short and direct response. 30.89. What is the ratio of the SF6 emissions (in thousand metric tons of CO2 equivalent) of 2008 in Greece to that in Iceland?
Ensure brevity in your answer.  28.85. What is the ratio of the SF6 emissions (in thousand metric tons of CO2 equivalent) in 1990 in Hong Kong to that in Hungary?
Keep it short and to the point. 20.38. What is the ratio of the SF6 emissions (in thousand metric tons of CO2 equivalent) of 2000 in Hong Kong to that in Hungary?
Offer a very short reply. 6.16. What is the ratio of the SF6 emissions (in thousand metric tons of CO2 equivalent) in 2005 in Hong Kong to that in Hungary?
Ensure brevity in your answer.  3.97. What is the ratio of the SF6 emissions (in thousand metric tons of CO2 equivalent) of 2008 in Hong Kong to that in Hungary?
Offer a very short reply. 4.75. What is the ratio of the SF6 emissions (in thousand metric tons of CO2 equivalent) in 1990 in Hong Kong to that in Iceland?
Offer a terse response. 108.29. What is the ratio of the SF6 emissions (in thousand metric tons of CO2 equivalent) in 2000 in Hong Kong to that in Iceland?
Your answer should be compact. 8.68. What is the ratio of the SF6 emissions (in thousand metric tons of CO2 equivalent) of 2008 in Hong Kong to that in Iceland?
Ensure brevity in your answer.  34.35. What is the ratio of the SF6 emissions (in thousand metric tons of CO2 equivalent) of 1990 in Hungary to that in Iceland?
Offer a terse response. 5.31. What is the ratio of the SF6 emissions (in thousand metric tons of CO2 equivalent) of 2000 in Hungary to that in Iceland?
Offer a terse response. 1.41. What is the ratio of the SF6 emissions (in thousand metric tons of CO2 equivalent) in 2005 in Hungary to that in Iceland?
Your response must be concise. 8.57. What is the ratio of the SF6 emissions (in thousand metric tons of CO2 equivalent) of 2008 in Hungary to that in Iceland?
Make the answer very short. 7.22. What is the difference between the highest and the second highest SF6 emissions (in thousand metric tons of CO2 equivalent) of 1990?
Provide a short and direct response. 2330.1. What is the difference between the highest and the second highest SF6 emissions (in thousand metric tons of CO2 equivalent) in 2000?
Your answer should be compact. 3151.9. What is the difference between the highest and the second highest SF6 emissions (in thousand metric tons of CO2 equivalent) of 2005?
Give a very brief answer. 3833.8. What is the difference between the highest and the second highest SF6 emissions (in thousand metric tons of CO2 equivalent) of 2008?
Provide a short and direct response. 4684.9. What is the difference between the highest and the lowest SF6 emissions (in thousand metric tons of CO2 equivalent) in 1990?
Offer a very short reply. 5559.4. What is the difference between the highest and the lowest SF6 emissions (in thousand metric tons of CO2 equivalent) in 2000?
Your response must be concise. 5562.5. What is the difference between the highest and the lowest SF6 emissions (in thousand metric tons of CO2 equivalent) in 2005?
Offer a terse response. 5439.7. What is the difference between the highest and the lowest SF6 emissions (in thousand metric tons of CO2 equivalent) of 2008?
Give a very brief answer. 6465.6. 